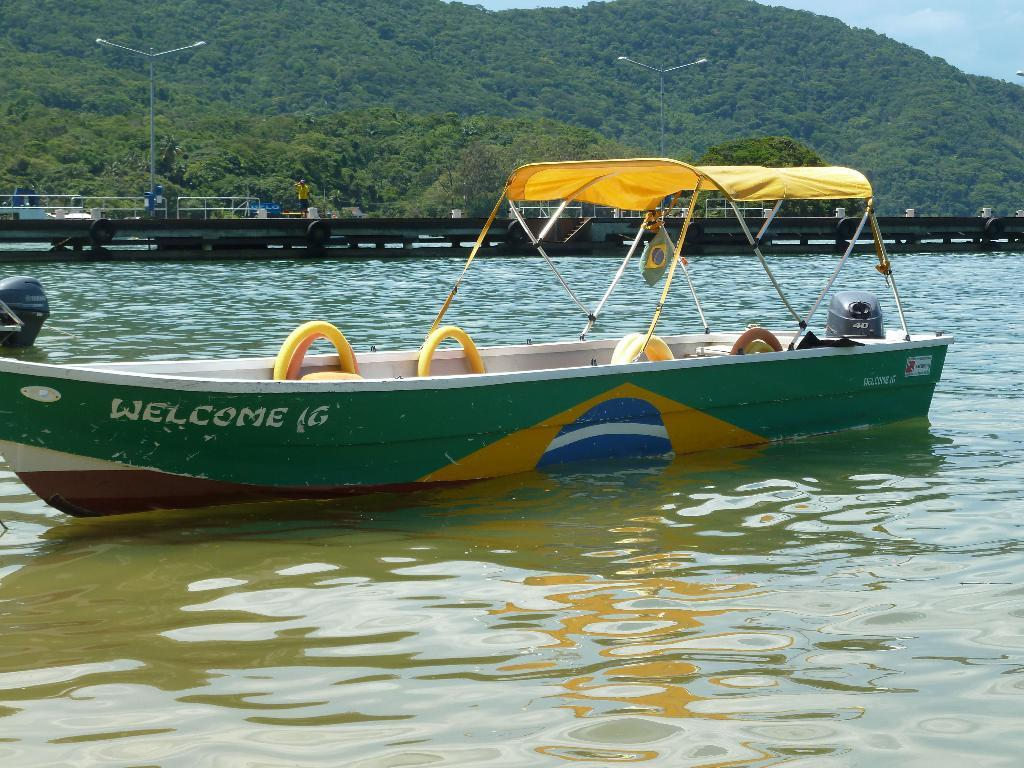What is the main subject of the image? The main subject of the image is a boat sailing in the water. What can be seen in the background of the image? In the backdrop, there is a bridge and a mountain with trees. How would you describe the sky in the image? The sky is clear in the image. How many amusement rides are present in the image? There are no amusement rides present in the image. Can you describe the person operating the boat in the image? There is no person operating the boat visible in the image. 